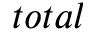<formula> <loc_0><loc_0><loc_500><loc_500>t o t a l</formula> 